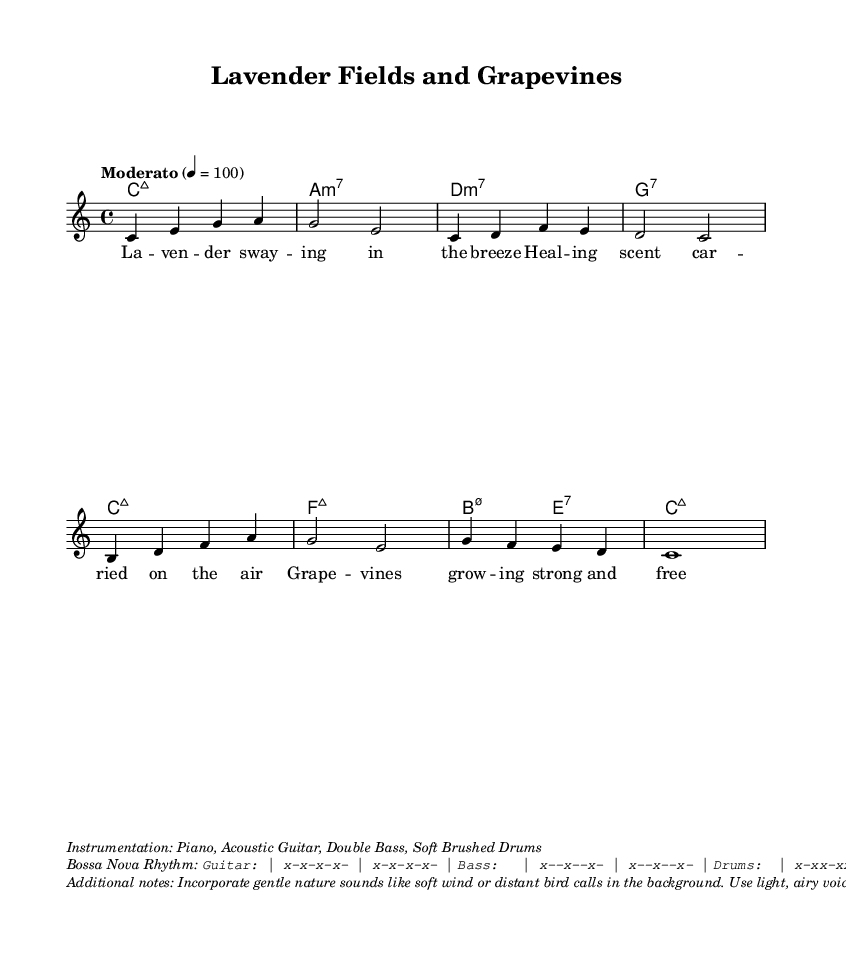What is the key signature of this music? The key signature is C major, which has no sharps or flats.
Answer: C major What is the time signature of this music? The time signature is indicated at the beginning of the music and is shown as 4/4, meaning there are four beats in each measure.
Answer: 4/4 What is the tempo marking for this piece? The tempo marking states "Moderato," which indicates a moderate pace. The specific speed is set at 100 beats per minute.
Answer: Moderato How many measures are in the melody section? By counting the measures in the melody section, we can see there are a total of 8 measures present.
Answer: 8 Which chords are used in the harmonic progression? The listed chords in the harmonic progression include Cmaj7, Am7, Dm7, G7, Fmaj7, Bm7.5-5, and E7, creating a rich harmonic backdrop.
Answer: Cmaj7, Am7, Dm7, G7, Fmaj7, Bm7.5-5, E7 What type of rhythm is indicated for the guitar part? The rhythm indicates a consistent Bossa Nova pattern, which is shown as repeated strumming and bass notes in a syncopated manner.
Answer: Bossa Nova What gentle sound features are suggested in the arrangement? The piece suggests incorporating gentle nature sounds like soft wind or distant bird calls, which add to the relaxing atmosphere.
Answer: Nature sounds 